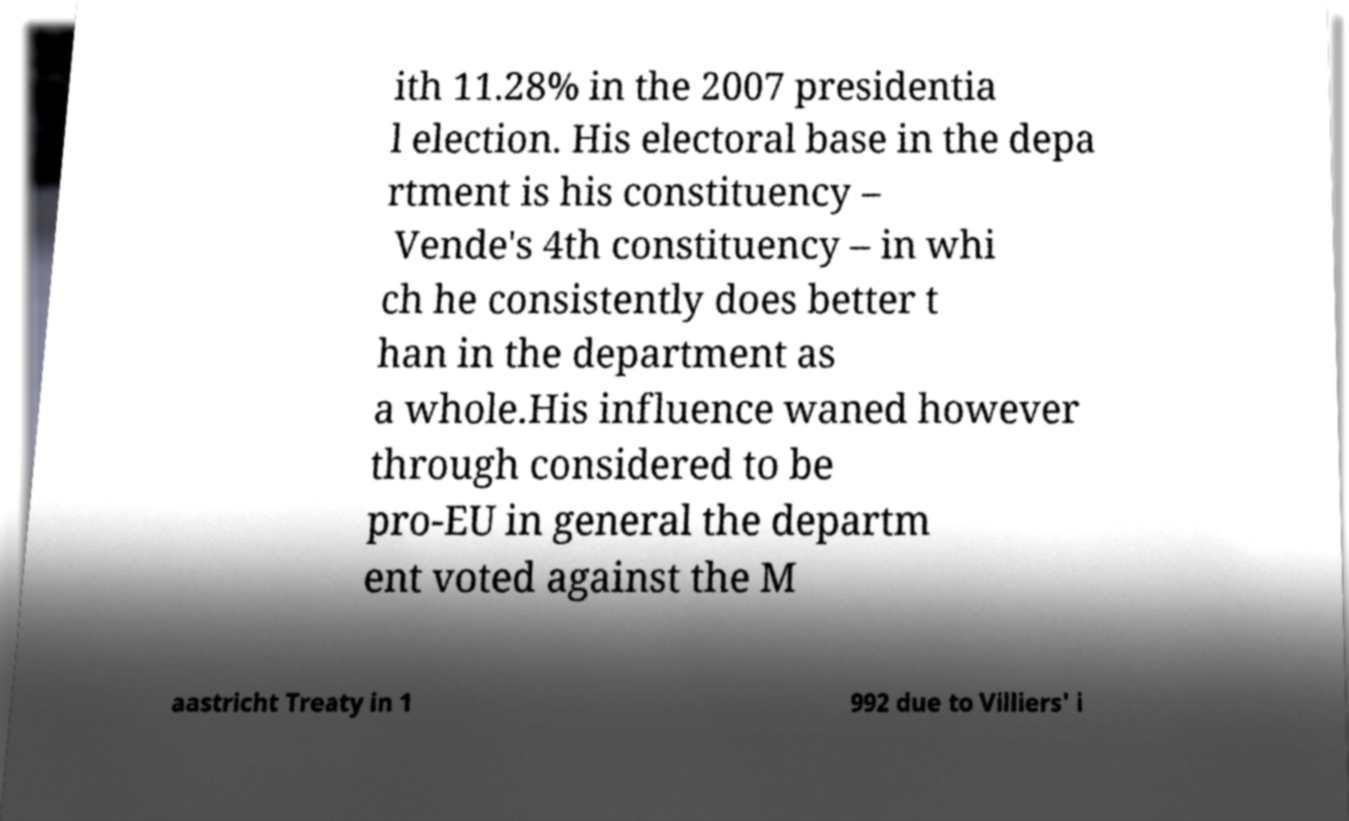I need the written content from this picture converted into text. Can you do that? ith 11.28% in the 2007 presidentia l election. His electoral base in the depa rtment is his constituency – Vende's 4th constituency – in whi ch he consistently does better t han in the department as a whole.His influence waned however through considered to be pro-EU in general the departm ent voted against the M aastricht Treaty in 1 992 due to Villiers' i 